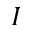<formula> <loc_0><loc_0><loc_500><loc_500>I</formula> 